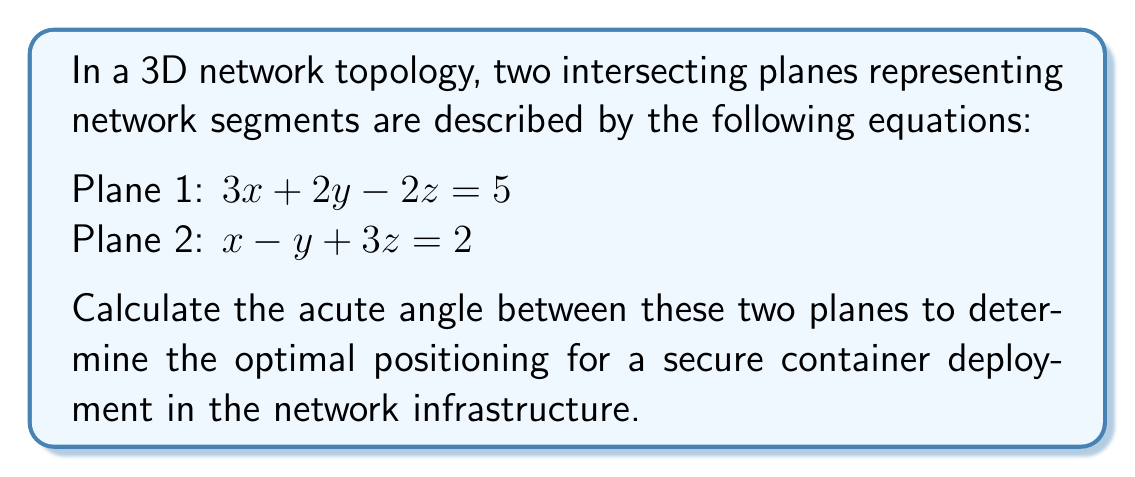Provide a solution to this math problem. To find the angle between two intersecting planes, we can use the following steps:

1. Identify the normal vectors of both planes:
   Plane 1: $\vec{n_1} = (3, 2, -2)$
   Plane 2: $\vec{n_2} = (1, -1, 3)$

2. Calculate the angle $\theta$ between the normal vectors using the dot product formula:

   $$\cos \theta = \frac{\vec{n_1} \cdot \vec{n_2}}{|\vec{n_1}| |\vec{n_2}|}$$

3. Compute the dot product $\vec{n_1} \cdot \vec{n_2}$:
   $\vec{n_1} \cdot \vec{n_2} = 3(1) + 2(-1) + (-2)(3) = 3 - 2 - 6 = -5$

4. Calculate the magnitudes of the normal vectors:
   $|\vec{n_1}| = \sqrt{3^2 + 2^2 + (-2)^2} = \sqrt{17}$
   $|\vec{n_2}| = \sqrt{1^2 + (-1)^2 + 3^2} = \sqrt{11}$

5. Substitute the values into the formula:

   $$\cos \theta = \frac{-5}{\sqrt{17} \sqrt{11}}$$

6. Take the inverse cosine (arccos) of both sides:

   $$\theta = \arccos\left(\frac{-5}{\sqrt{17} \sqrt{11}}\right)$$

7. Calculate the result:
   $\theta \approx 2.214$ radians or $126.87°$

8. Since we want the acute angle, we subtract this result from 180°:
   $180° - 126.87° = 53.13°$
Answer: $53.13°$ 